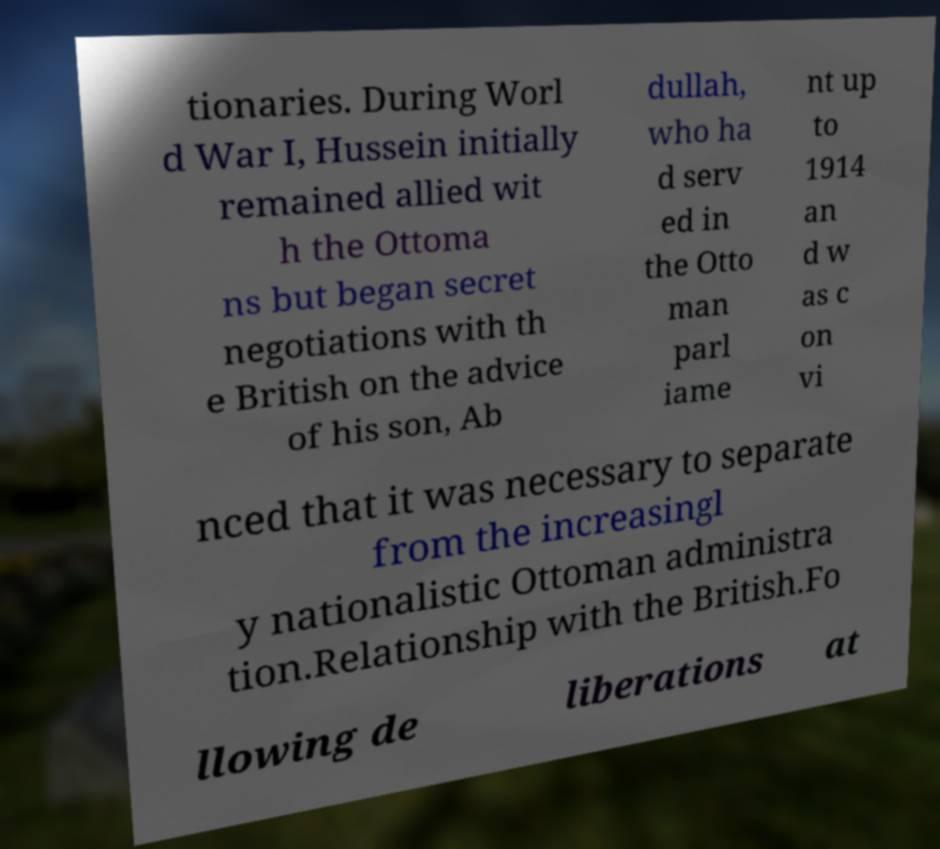There's text embedded in this image that I need extracted. Can you transcribe it verbatim? tionaries. During Worl d War I, Hussein initially remained allied wit h the Ottoma ns but began secret negotiations with th e British on the advice of his son, Ab dullah, who ha d serv ed in the Otto man parl iame nt up to 1914 an d w as c on vi nced that it was necessary to separate from the increasingl y nationalistic Ottoman administra tion.Relationship with the British.Fo llowing de liberations at 